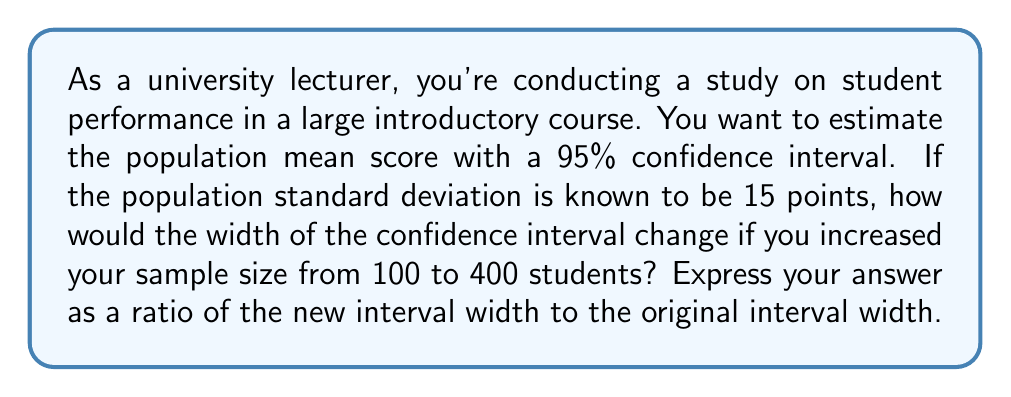Could you help me with this problem? Let's approach this step-by-step:

1) The formula for the margin of error (half the width) of a confidence interval for a population mean is:

   $E = z_{\alpha/2} \cdot \frac{\sigma}{\sqrt{n}}$

   Where $z_{\alpha/2}$ is the critical value, $\sigma$ is the population standard deviation, and $n$ is the sample size.

2) The width of the confidence interval is twice the margin of error:

   $\text{Width} = 2E = 2z_{\alpha/2} \cdot \frac{\sigma}{\sqrt{n}}$

3) For a 95% confidence interval, $z_{\alpha/2} = 1.96$. The population standard deviation $\sigma = 15$.

4) For the original sample size $n_1 = 100$:
   
   $\text{Width}_1 = 2 \cdot 1.96 \cdot \frac{15}{\sqrt{100}} = 2 \cdot 1.96 \cdot \frac{15}{10} = 5.88$

5) For the new sample size $n_2 = 400$:
   
   $\text{Width}_2 = 2 \cdot 1.96 \cdot \frac{15}{\sqrt{400}} = 2 \cdot 1.96 \cdot \frac{15}{20} = 2.94$

6) The ratio of the new width to the original width is:

   $\frac{\text{Width}_2}{\text{Width}_1} = \frac{2.94}{5.88} = 0.5$

7) We can also derive this directly from the formula:

   $\frac{\text{Width}_2}{\text{Width}_1} = \frac{\frac{1}{\sqrt{n_2}}}{\frac{1}{\sqrt{n_1}}} = \sqrt{\frac{n_1}{n_2}} = \sqrt{\frac{100}{400}} = \frac{1}{2} = 0.5$

This shows that doubling the sample size reduces the width of the confidence interval by a factor of $\frac{1}{\sqrt{2}}$.
Answer: $0.5$ or $\frac{1}{2}$ 